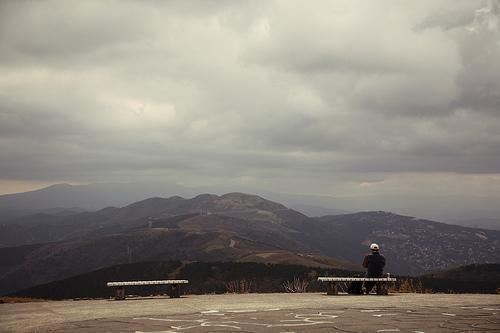How many people are in the photo?
Give a very brief answer. 1. 